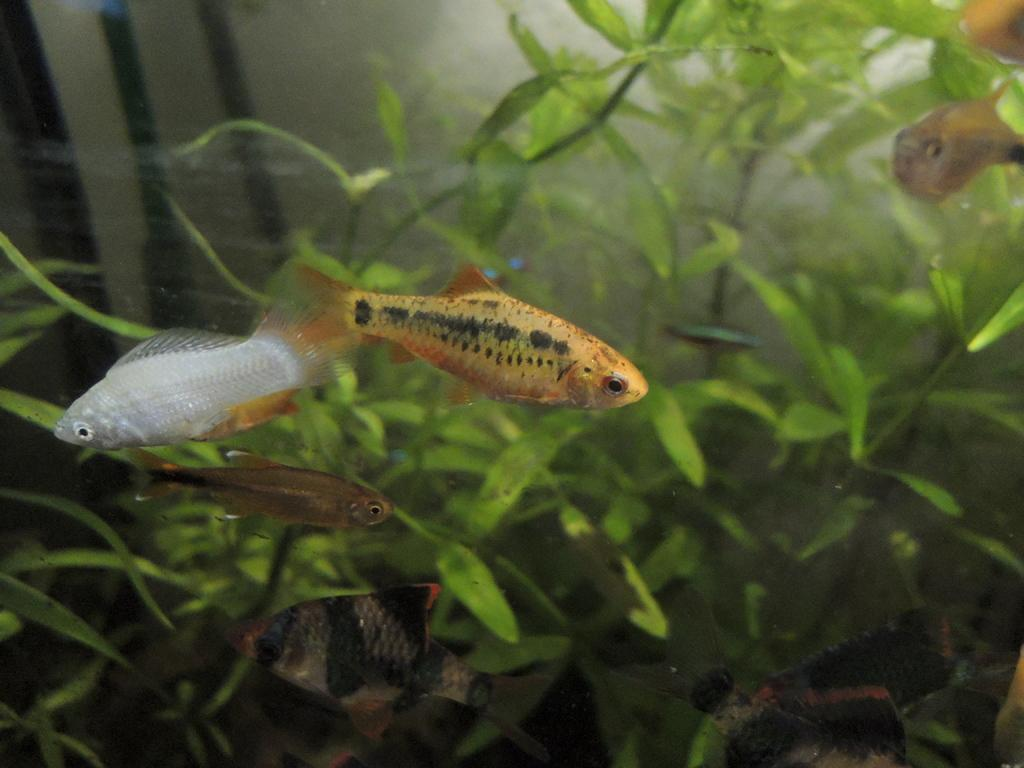What type of animals can be seen in the image? There are fishes in the image. What other elements are present in the image besides the fishes? There are plants visible in the image. Where are the fishes and plants located in the image? The fishes and plants are underwater in the image. What grade does the wren receive for its performance in the image? There is no wren present in the image, so it cannot be graded. 